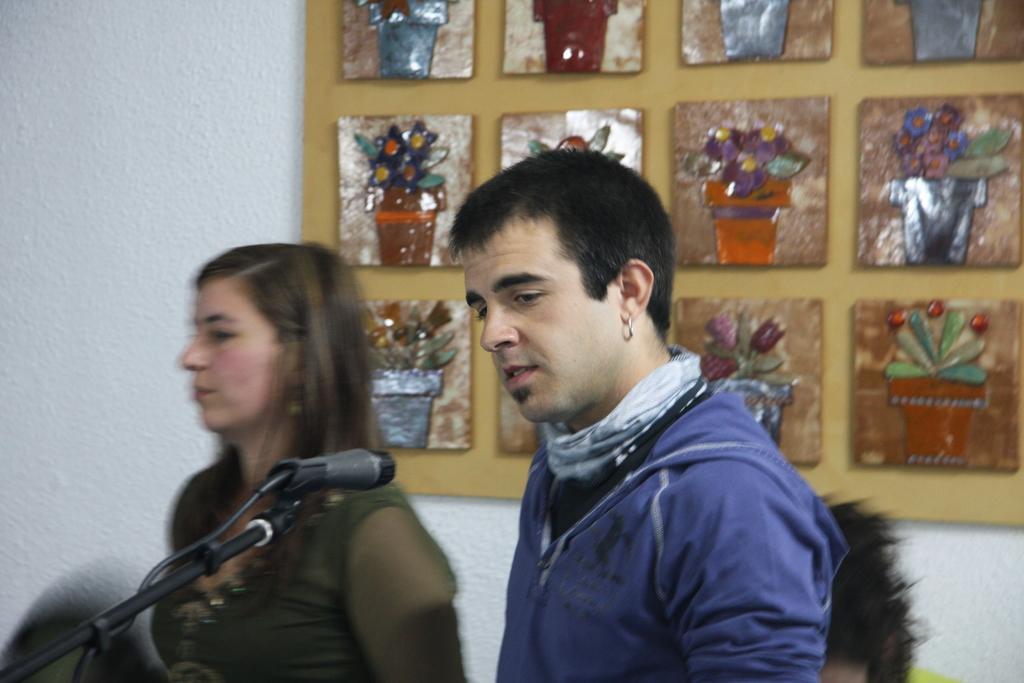Please provide a concise description of this image. In the picture there is a man who is wearing hoodie and earring. Here we can see a woman who is standing near to the wall. On the bottom left corner there is a mic. On the top right we can see photo frames. On the bottom right corner we can see another woman who is wearing green dress. 